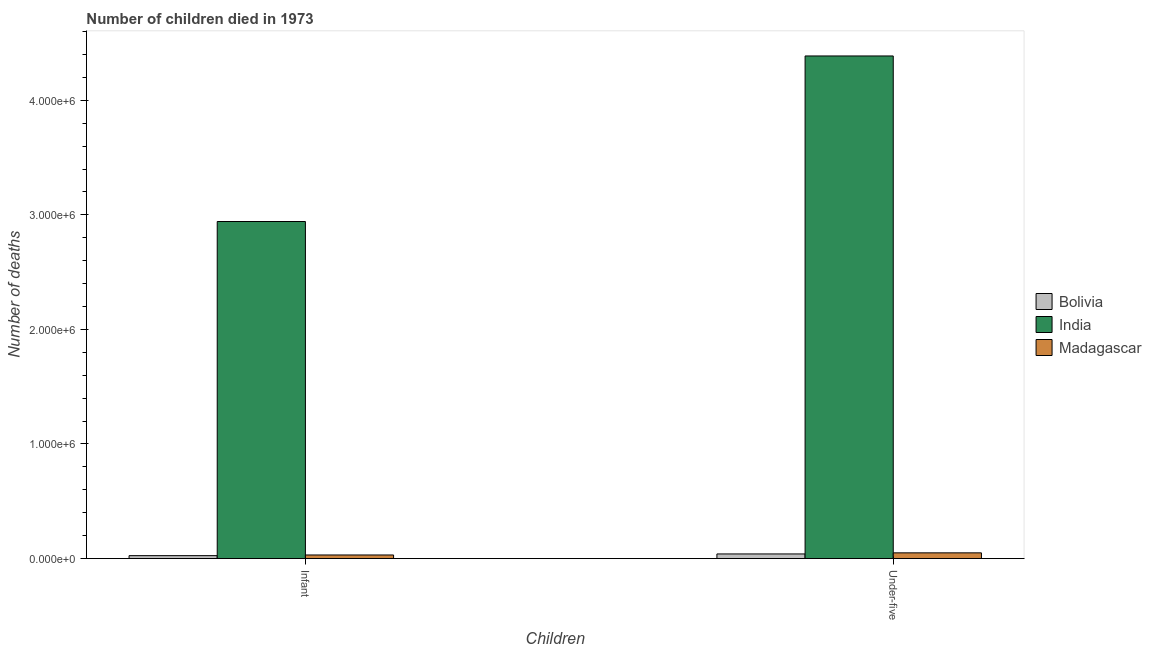How many different coloured bars are there?
Offer a very short reply. 3. How many groups of bars are there?
Your answer should be compact. 2. Are the number of bars on each tick of the X-axis equal?
Keep it short and to the point. Yes. What is the label of the 1st group of bars from the left?
Ensure brevity in your answer.  Infant. What is the number of infant deaths in India?
Provide a succinct answer. 2.94e+06. Across all countries, what is the maximum number of infant deaths?
Ensure brevity in your answer.  2.94e+06. Across all countries, what is the minimum number of infant deaths?
Provide a succinct answer. 2.55e+04. In which country was the number of infant deaths minimum?
Keep it short and to the point. Bolivia. What is the total number of infant deaths in the graph?
Keep it short and to the point. 3.00e+06. What is the difference between the number of infant deaths in India and that in Madagascar?
Ensure brevity in your answer.  2.91e+06. What is the difference between the number of under-five deaths in Madagascar and the number of infant deaths in Bolivia?
Give a very brief answer. 2.44e+04. What is the average number of infant deaths per country?
Keep it short and to the point. 1.00e+06. What is the difference between the number of infant deaths and number of under-five deaths in Madagascar?
Your response must be concise. -1.86e+04. What is the ratio of the number of under-five deaths in Madagascar to that in India?
Provide a succinct answer. 0.01. Is the number of infant deaths in Madagascar less than that in Bolivia?
Provide a succinct answer. No. In how many countries, is the number of under-five deaths greater than the average number of under-five deaths taken over all countries?
Provide a succinct answer. 1. What does the 1st bar from the left in Under-five represents?
Ensure brevity in your answer.  Bolivia. Are all the bars in the graph horizontal?
Your response must be concise. No. How many countries are there in the graph?
Make the answer very short. 3. What is the difference between two consecutive major ticks on the Y-axis?
Provide a succinct answer. 1.00e+06. Are the values on the major ticks of Y-axis written in scientific E-notation?
Your answer should be compact. Yes. Does the graph contain any zero values?
Keep it short and to the point. No. How are the legend labels stacked?
Your response must be concise. Vertical. What is the title of the graph?
Offer a very short reply. Number of children died in 1973. What is the label or title of the X-axis?
Offer a terse response. Children. What is the label or title of the Y-axis?
Make the answer very short. Number of deaths. What is the Number of deaths in Bolivia in Infant?
Provide a succinct answer. 2.55e+04. What is the Number of deaths of India in Infant?
Your response must be concise. 2.94e+06. What is the Number of deaths in Madagascar in Infant?
Give a very brief answer. 3.13e+04. What is the Number of deaths in Bolivia in Under-five?
Provide a succinct answer. 4.03e+04. What is the Number of deaths of India in Under-five?
Provide a succinct answer. 4.39e+06. What is the Number of deaths of Madagascar in Under-five?
Provide a short and direct response. 4.99e+04. Across all Children, what is the maximum Number of deaths of Bolivia?
Make the answer very short. 4.03e+04. Across all Children, what is the maximum Number of deaths of India?
Offer a very short reply. 4.39e+06. Across all Children, what is the maximum Number of deaths of Madagascar?
Your response must be concise. 4.99e+04. Across all Children, what is the minimum Number of deaths of Bolivia?
Keep it short and to the point. 2.55e+04. Across all Children, what is the minimum Number of deaths in India?
Your response must be concise. 2.94e+06. Across all Children, what is the minimum Number of deaths of Madagascar?
Your answer should be compact. 3.13e+04. What is the total Number of deaths in Bolivia in the graph?
Provide a succinct answer. 6.58e+04. What is the total Number of deaths of India in the graph?
Make the answer very short. 7.33e+06. What is the total Number of deaths of Madagascar in the graph?
Your response must be concise. 8.12e+04. What is the difference between the Number of deaths in Bolivia in Infant and that in Under-five?
Make the answer very short. -1.48e+04. What is the difference between the Number of deaths of India in Infant and that in Under-five?
Give a very brief answer. -1.44e+06. What is the difference between the Number of deaths in Madagascar in Infant and that in Under-five?
Provide a short and direct response. -1.86e+04. What is the difference between the Number of deaths in Bolivia in Infant and the Number of deaths in India in Under-five?
Offer a very short reply. -4.36e+06. What is the difference between the Number of deaths of Bolivia in Infant and the Number of deaths of Madagascar in Under-five?
Give a very brief answer. -2.44e+04. What is the difference between the Number of deaths of India in Infant and the Number of deaths of Madagascar in Under-five?
Your answer should be compact. 2.89e+06. What is the average Number of deaths of Bolivia per Children?
Your response must be concise. 3.29e+04. What is the average Number of deaths in India per Children?
Make the answer very short. 3.66e+06. What is the average Number of deaths in Madagascar per Children?
Make the answer very short. 4.06e+04. What is the difference between the Number of deaths of Bolivia and Number of deaths of India in Infant?
Your answer should be very brief. -2.92e+06. What is the difference between the Number of deaths of Bolivia and Number of deaths of Madagascar in Infant?
Your answer should be very brief. -5770. What is the difference between the Number of deaths in India and Number of deaths in Madagascar in Infant?
Offer a very short reply. 2.91e+06. What is the difference between the Number of deaths of Bolivia and Number of deaths of India in Under-five?
Provide a succinct answer. -4.35e+06. What is the difference between the Number of deaths of Bolivia and Number of deaths of Madagascar in Under-five?
Your response must be concise. -9564. What is the difference between the Number of deaths of India and Number of deaths of Madagascar in Under-five?
Ensure brevity in your answer.  4.34e+06. What is the ratio of the Number of deaths of Bolivia in Infant to that in Under-five?
Your answer should be compact. 0.63. What is the ratio of the Number of deaths of India in Infant to that in Under-five?
Your response must be concise. 0.67. What is the ratio of the Number of deaths in Madagascar in Infant to that in Under-five?
Ensure brevity in your answer.  0.63. What is the difference between the highest and the second highest Number of deaths in Bolivia?
Ensure brevity in your answer.  1.48e+04. What is the difference between the highest and the second highest Number of deaths of India?
Offer a terse response. 1.44e+06. What is the difference between the highest and the second highest Number of deaths in Madagascar?
Give a very brief answer. 1.86e+04. What is the difference between the highest and the lowest Number of deaths of Bolivia?
Provide a short and direct response. 1.48e+04. What is the difference between the highest and the lowest Number of deaths of India?
Ensure brevity in your answer.  1.44e+06. What is the difference between the highest and the lowest Number of deaths in Madagascar?
Offer a very short reply. 1.86e+04. 